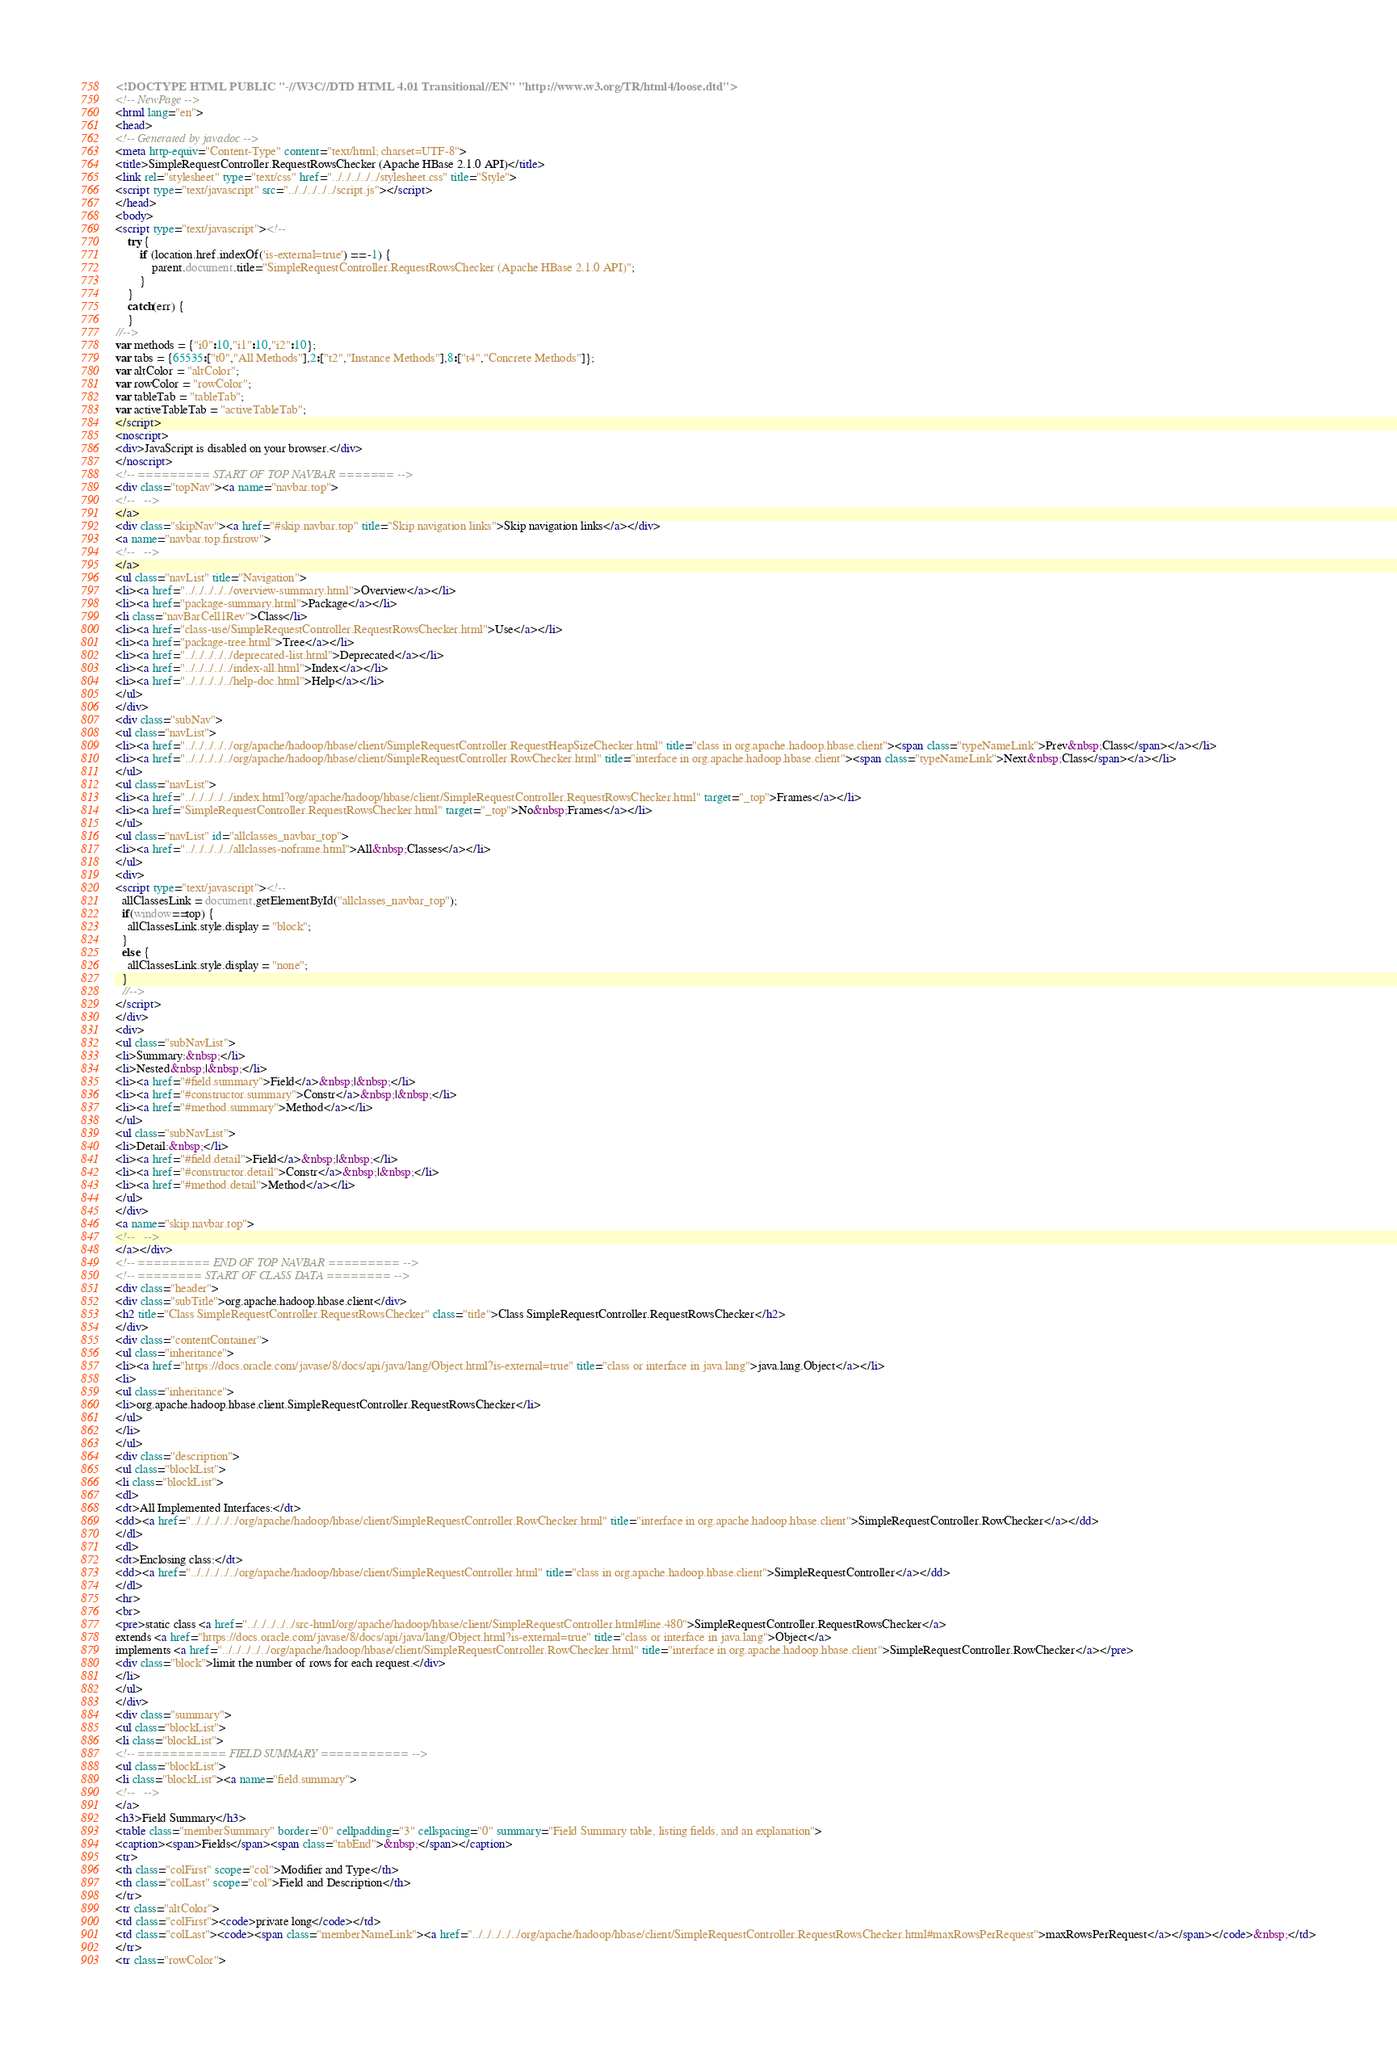<code> <loc_0><loc_0><loc_500><loc_500><_HTML_><!DOCTYPE HTML PUBLIC "-//W3C//DTD HTML 4.01 Transitional//EN" "http://www.w3.org/TR/html4/loose.dtd">
<!-- NewPage -->
<html lang="en">
<head>
<!-- Generated by javadoc -->
<meta http-equiv="Content-Type" content="text/html; charset=UTF-8">
<title>SimpleRequestController.RequestRowsChecker (Apache HBase 2.1.0 API)</title>
<link rel="stylesheet" type="text/css" href="../../../../../stylesheet.css" title="Style">
<script type="text/javascript" src="../../../../../script.js"></script>
</head>
<body>
<script type="text/javascript"><!--
    try {
        if (location.href.indexOf('is-external=true') == -1) {
            parent.document.title="SimpleRequestController.RequestRowsChecker (Apache HBase 2.1.0 API)";
        }
    }
    catch(err) {
    }
//-->
var methods = {"i0":10,"i1":10,"i2":10};
var tabs = {65535:["t0","All Methods"],2:["t2","Instance Methods"],8:["t4","Concrete Methods"]};
var altColor = "altColor";
var rowColor = "rowColor";
var tableTab = "tableTab";
var activeTableTab = "activeTableTab";
</script>
<noscript>
<div>JavaScript is disabled on your browser.</div>
</noscript>
<!-- ========= START OF TOP NAVBAR ======= -->
<div class="topNav"><a name="navbar.top">
<!--   -->
</a>
<div class="skipNav"><a href="#skip.navbar.top" title="Skip navigation links">Skip navigation links</a></div>
<a name="navbar.top.firstrow">
<!--   -->
</a>
<ul class="navList" title="Navigation">
<li><a href="../../../../../overview-summary.html">Overview</a></li>
<li><a href="package-summary.html">Package</a></li>
<li class="navBarCell1Rev">Class</li>
<li><a href="class-use/SimpleRequestController.RequestRowsChecker.html">Use</a></li>
<li><a href="package-tree.html">Tree</a></li>
<li><a href="../../../../../deprecated-list.html">Deprecated</a></li>
<li><a href="../../../../../index-all.html">Index</a></li>
<li><a href="../../../../../help-doc.html">Help</a></li>
</ul>
</div>
<div class="subNav">
<ul class="navList">
<li><a href="../../../../../org/apache/hadoop/hbase/client/SimpleRequestController.RequestHeapSizeChecker.html" title="class in org.apache.hadoop.hbase.client"><span class="typeNameLink">Prev&nbsp;Class</span></a></li>
<li><a href="../../../../../org/apache/hadoop/hbase/client/SimpleRequestController.RowChecker.html" title="interface in org.apache.hadoop.hbase.client"><span class="typeNameLink">Next&nbsp;Class</span></a></li>
</ul>
<ul class="navList">
<li><a href="../../../../../index.html?org/apache/hadoop/hbase/client/SimpleRequestController.RequestRowsChecker.html" target="_top">Frames</a></li>
<li><a href="SimpleRequestController.RequestRowsChecker.html" target="_top">No&nbsp;Frames</a></li>
</ul>
<ul class="navList" id="allclasses_navbar_top">
<li><a href="../../../../../allclasses-noframe.html">All&nbsp;Classes</a></li>
</ul>
<div>
<script type="text/javascript"><!--
  allClassesLink = document.getElementById("allclasses_navbar_top");
  if(window==top) {
    allClassesLink.style.display = "block";
  }
  else {
    allClassesLink.style.display = "none";
  }
  //-->
</script>
</div>
<div>
<ul class="subNavList">
<li>Summary:&nbsp;</li>
<li>Nested&nbsp;|&nbsp;</li>
<li><a href="#field.summary">Field</a>&nbsp;|&nbsp;</li>
<li><a href="#constructor.summary">Constr</a>&nbsp;|&nbsp;</li>
<li><a href="#method.summary">Method</a></li>
</ul>
<ul class="subNavList">
<li>Detail:&nbsp;</li>
<li><a href="#field.detail">Field</a>&nbsp;|&nbsp;</li>
<li><a href="#constructor.detail">Constr</a>&nbsp;|&nbsp;</li>
<li><a href="#method.detail">Method</a></li>
</ul>
</div>
<a name="skip.navbar.top">
<!--   -->
</a></div>
<!-- ========= END OF TOP NAVBAR ========= -->
<!-- ======== START OF CLASS DATA ======== -->
<div class="header">
<div class="subTitle">org.apache.hadoop.hbase.client</div>
<h2 title="Class SimpleRequestController.RequestRowsChecker" class="title">Class SimpleRequestController.RequestRowsChecker</h2>
</div>
<div class="contentContainer">
<ul class="inheritance">
<li><a href="https://docs.oracle.com/javase/8/docs/api/java/lang/Object.html?is-external=true" title="class or interface in java.lang">java.lang.Object</a></li>
<li>
<ul class="inheritance">
<li>org.apache.hadoop.hbase.client.SimpleRequestController.RequestRowsChecker</li>
</ul>
</li>
</ul>
<div class="description">
<ul class="blockList">
<li class="blockList">
<dl>
<dt>All Implemented Interfaces:</dt>
<dd><a href="../../../../../org/apache/hadoop/hbase/client/SimpleRequestController.RowChecker.html" title="interface in org.apache.hadoop.hbase.client">SimpleRequestController.RowChecker</a></dd>
</dl>
<dl>
<dt>Enclosing class:</dt>
<dd><a href="../../../../../org/apache/hadoop/hbase/client/SimpleRequestController.html" title="class in org.apache.hadoop.hbase.client">SimpleRequestController</a></dd>
</dl>
<hr>
<br>
<pre>static class <a href="../../../../../src-html/org/apache/hadoop/hbase/client/SimpleRequestController.html#line.480">SimpleRequestController.RequestRowsChecker</a>
extends <a href="https://docs.oracle.com/javase/8/docs/api/java/lang/Object.html?is-external=true" title="class or interface in java.lang">Object</a>
implements <a href="../../../../../org/apache/hadoop/hbase/client/SimpleRequestController.RowChecker.html" title="interface in org.apache.hadoop.hbase.client">SimpleRequestController.RowChecker</a></pre>
<div class="block">limit the number of rows for each request.</div>
</li>
</ul>
</div>
<div class="summary">
<ul class="blockList">
<li class="blockList">
<!-- =========== FIELD SUMMARY =========== -->
<ul class="blockList">
<li class="blockList"><a name="field.summary">
<!--   -->
</a>
<h3>Field Summary</h3>
<table class="memberSummary" border="0" cellpadding="3" cellspacing="0" summary="Field Summary table, listing fields, and an explanation">
<caption><span>Fields</span><span class="tabEnd">&nbsp;</span></caption>
<tr>
<th class="colFirst" scope="col">Modifier and Type</th>
<th class="colLast" scope="col">Field and Description</th>
</tr>
<tr class="altColor">
<td class="colFirst"><code>private long</code></td>
<td class="colLast"><code><span class="memberNameLink"><a href="../../../../../org/apache/hadoop/hbase/client/SimpleRequestController.RequestRowsChecker.html#maxRowsPerRequest">maxRowsPerRequest</a></span></code>&nbsp;</td>
</tr>
<tr class="rowColor"></code> 